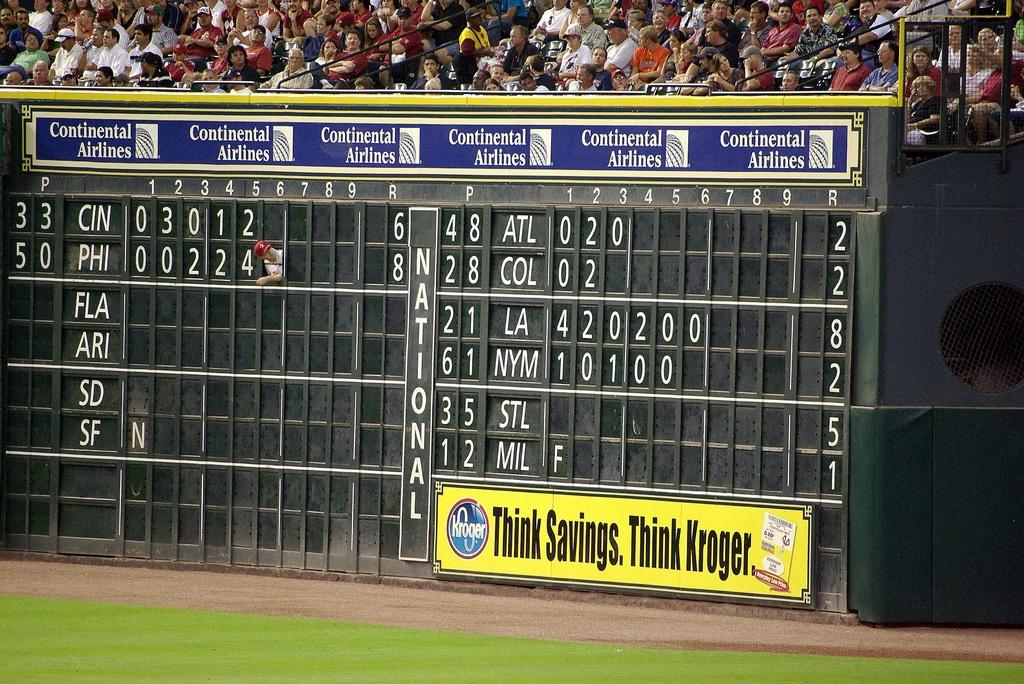<image>
Give a short and clear explanation of the subsequent image. A large black baseball scoreboard with Continental Airlines on it. 